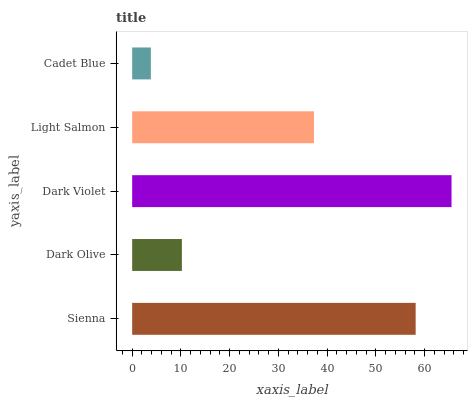Is Cadet Blue the minimum?
Answer yes or no. Yes. Is Dark Violet the maximum?
Answer yes or no. Yes. Is Dark Olive the minimum?
Answer yes or no. No. Is Dark Olive the maximum?
Answer yes or no. No. Is Sienna greater than Dark Olive?
Answer yes or no. Yes. Is Dark Olive less than Sienna?
Answer yes or no. Yes. Is Dark Olive greater than Sienna?
Answer yes or no. No. Is Sienna less than Dark Olive?
Answer yes or no. No. Is Light Salmon the high median?
Answer yes or no. Yes. Is Light Salmon the low median?
Answer yes or no. Yes. Is Cadet Blue the high median?
Answer yes or no. No. Is Sienna the low median?
Answer yes or no. No. 